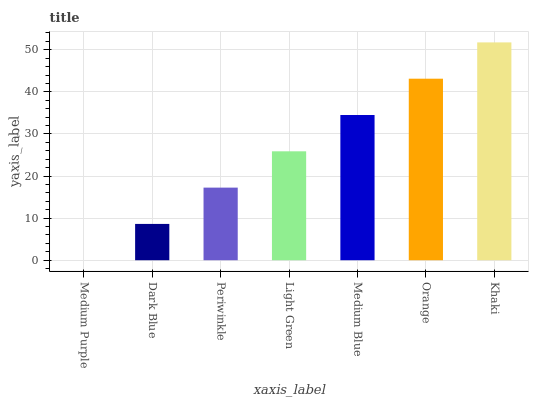Is Medium Purple the minimum?
Answer yes or no. Yes. Is Khaki the maximum?
Answer yes or no. Yes. Is Dark Blue the minimum?
Answer yes or no. No. Is Dark Blue the maximum?
Answer yes or no. No. Is Dark Blue greater than Medium Purple?
Answer yes or no. Yes. Is Medium Purple less than Dark Blue?
Answer yes or no. Yes. Is Medium Purple greater than Dark Blue?
Answer yes or no. No. Is Dark Blue less than Medium Purple?
Answer yes or no. No. Is Light Green the high median?
Answer yes or no. Yes. Is Light Green the low median?
Answer yes or no. Yes. Is Khaki the high median?
Answer yes or no. No. Is Orange the low median?
Answer yes or no. No. 